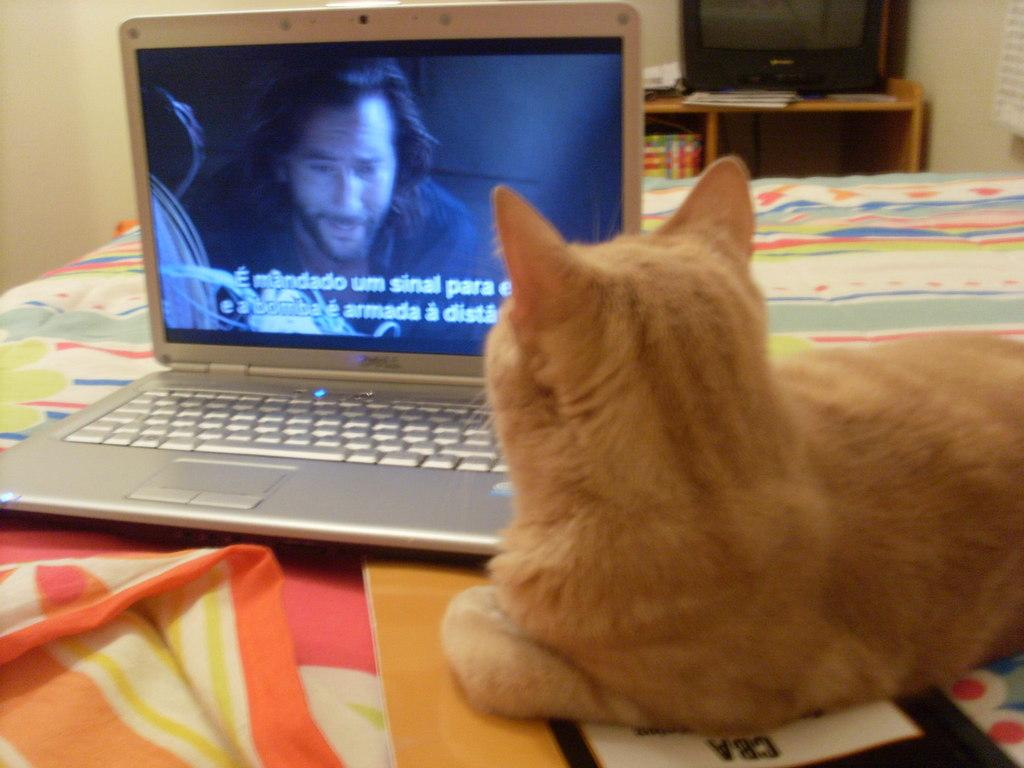What animal can be seen in the image? There is a cat in the image. Where is the cat located? The cat is lying on the bed. What is the cat doing in the image? The cat is watching a laptop. What can be seen in the background of the image? There is a monitor on a table in the background. What type of bait is the cat using to catch fish in the image? There is no indication of fishing or bait in the image; the cat is watching a laptop. How much salt is present on the cat's paws in the image? There is no salt visible on the cat's paws in the image. 